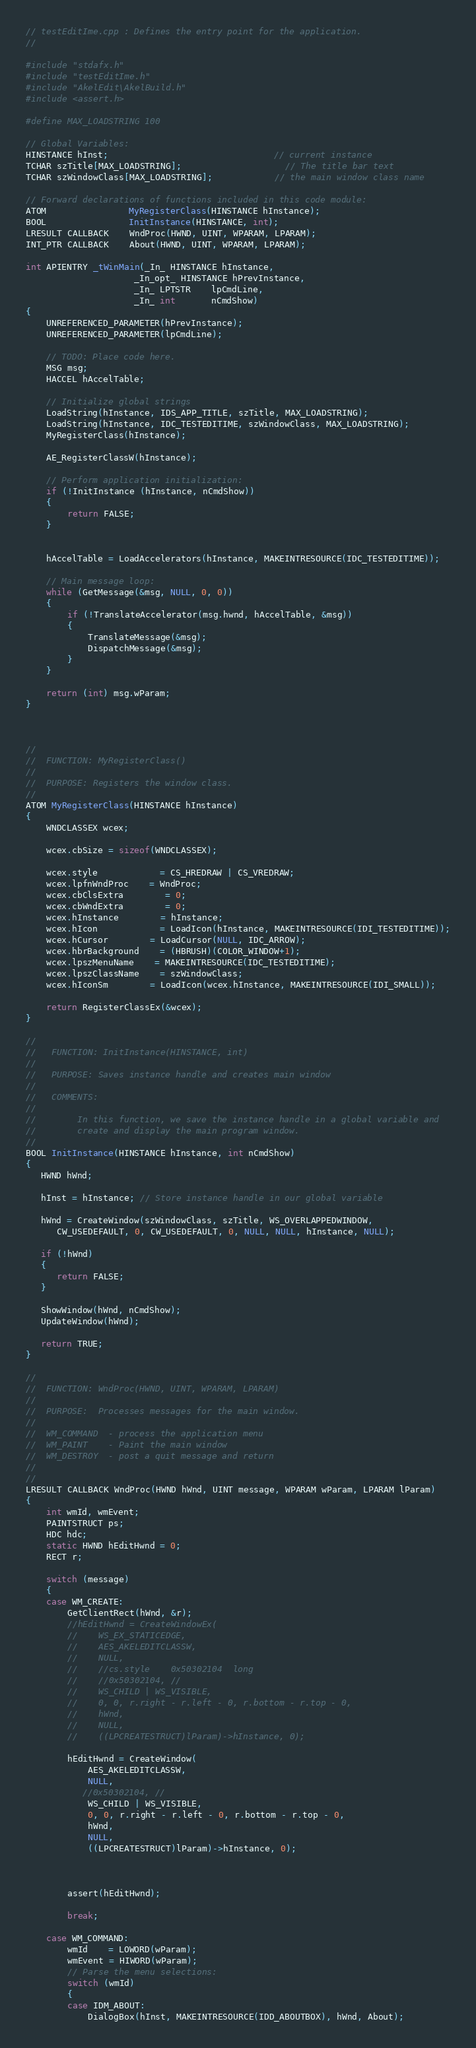Convert code to text. <code><loc_0><loc_0><loc_500><loc_500><_C++_>// testEditIme.cpp : Defines the entry point for the application.
//

#include "stdafx.h"
#include "testEditIme.h"
#include "AkelEdit\AkelBuild.h"
#include <assert.h>

#define MAX_LOADSTRING 100

// Global Variables:
HINSTANCE hInst;								// current instance
TCHAR szTitle[MAX_LOADSTRING];					// The title bar text
TCHAR szWindowClass[MAX_LOADSTRING];			// the main window class name

// Forward declarations of functions included in this code module:
ATOM				MyRegisterClass(HINSTANCE hInstance);
BOOL				InitInstance(HINSTANCE, int);
LRESULT CALLBACK	WndProc(HWND, UINT, WPARAM, LPARAM);
INT_PTR CALLBACK	About(HWND, UINT, WPARAM, LPARAM);

int APIENTRY _tWinMain(_In_ HINSTANCE hInstance,
                     _In_opt_ HINSTANCE hPrevInstance,
                     _In_ LPTSTR    lpCmdLine,
                     _In_ int       nCmdShow)
{
	UNREFERENCED_PARAMETER(hPrevInstance);
	UNREFERENCED_PARAMETER(lpCmdLine);

 	// TODO: Place code here.
	MSG msg;
	HACCEL hAccelTable;

	// Initialize global strings
	LoadString(hInstance, IDS_APP_TITLE, szTitle, MAX_LOADSTRING);
	LoadString(hInstance, IDC_TESTEDITIME, szWindowClass, MAX_LOADSTRING);
	MyRegisterClass(hInstance);

    AE_RegisterClassW(hInstance);

	// Perform application initialization:
	if (!InitInstance (hInstance, nCmdShow))
	{
		return FALSE;
	}
    

	hAccelTable = LoadAccelerators(hInstance, MAKEINTRESOURCE(IDC_TESTEDITIME));

	// Main message loop:
	while (GetMessage(&msg, NULL, 0, 0))
	{
		if (!TranslateAccelerator(msg.hwnd, hAccelTable, &msg))
		{
			TranslateMessage(&msg);
			DispatchMessage(&msg);
		}
	}

	return (int) msg.wParam;
}



//
//  FUNCTION: MyRegisterClass()
//
//  PURPOSE: Registers the window class.
//
ATOM MyRegisterClass(HINSTANCE hInstance)
{
	WNDCLASSEX wcex;

	wcex.cbSize = sizeof(WNDCLASSEX);

	wcex.style			= CS_HREDRAW | CS_VREDRAW;
	wcex.lpfnWndProc	= WndProc;
	wcex.cbClsExtra		= 0;
	wcex.cbWndExtra		= 0;
	wcex.hInstance		= hInstance;
	wcex.hIcon			= LoadIcon(hInstance, MAKEINTRESOURCE(IDI_TESTEDITIME));
	wcex.hCursor		= LoadCursor(NULL, IDC_ARROW);
	wcex.hbrBackground	= (HBRUSH)(COLOR_WINDOW+1);
	wcex.lpszMenuName	= MAKEINTRESOURCE(IDC_TESTEDITIME);
	wcex.lpszClassName	= szWindowClass;
	wcex.hIconSm		= LoadIcon(wcex.hInstance, MAKEINTRESOURCE(IDI_SMALL));

	return RegisterClassEx(&wcex);
}

//
//   FUNCTION: InitInstance(HINSTANCE, int)
//
//   PURPOSE: Saves instance handle and creates main window
//
//   COMMENTS:
//
//        In this function, we save the instance handle in a global variable and
//        create and display the main program window.
//
BOOL InitInstance(HINSTANCE hInstance, int nCmdShow)
{
   HWND hWnd;

   hInst = hInstance; // Store instance handle in our global variable

   hWnd = CreateWindow(szWindowClass, szTitle, WS_OVERLAPPEDWINDOW,
      CW_USEDEFAULT, 0, CW_USEDEFAULT, 0, NULL, NULL, hInstance, NULL);

   if (!hWnd)
   {
      return FALSE;
   }

   ShowWindow(hWnd, nCmdShow);
   UpdateWindow(hWnd);

   return TRUE;
}

//
//  FUNCTION: WndProc(HWND, UINT, WPARAM, LPARAM)
//
//  PURPOSE:  Processes messages for the main window.
//
//  WM_COMMAND	- process the application menu
//  WM_PAINT	- Paint the main window
//  WM_DESTROY	- post a quit message and return
//
//
LRESULT CALLBACK WndProc(HWND hWnd, UINT message, WPARAM wParam, LPARAM lParam)
{
	int wmId, wmEvent;
	PAINTSTRUCT ps;
	HDC hdc;
    static HWND hEditHwnd = 0;
    RECT r;

	switch (message)
	{
    case WM_CREATE:
        GetClientRect(hWnd, &r);
        //hEditHwnd = CreateWindowEx(
        //    WS_EX_STATICEDGE, 
        //    AES_AKELEDITCLASSW, 
        //    NULL,
        //    //cs.style	0x50302104	long
        //    //0x50302104, //           
        //    WS_CHILD | WS_VISIBLE,
        //    0, 0, r.right - r.left - 0, r.bottom - r.top - 0, 
        //    hWnd, 
        //    NULL, 
        //    ((LPCREATESTRUCT)lParam)->hInstance, 0);

        hEditHwnd = CreateWindow(
            AES_AKELEDITCLASSW,
            NULL,
           //0x50302104, //           
            WS_CHILD | WS_VISIBLE,
            0, 0, r.right - r.left - 0, r.bottom - r.top - 0,
            hWnd,
            NULL,
            ((LPCREATESTRUCT)lParam)->hInstance, 0);



        assert(hEditHwnd);

        break;

	case WM_COMMAND:
		wmId    = LOWORD(wParam);
		wmEvent = HIWORD(wParam);
		// Parse the menu selections:
		switch (wmId)
		{
		case IDM_ABOUT:
			DialogBox(hInst, MAKEINTRESOURCE(IDD_ABOUTBOX), hWnd, About);</code> 